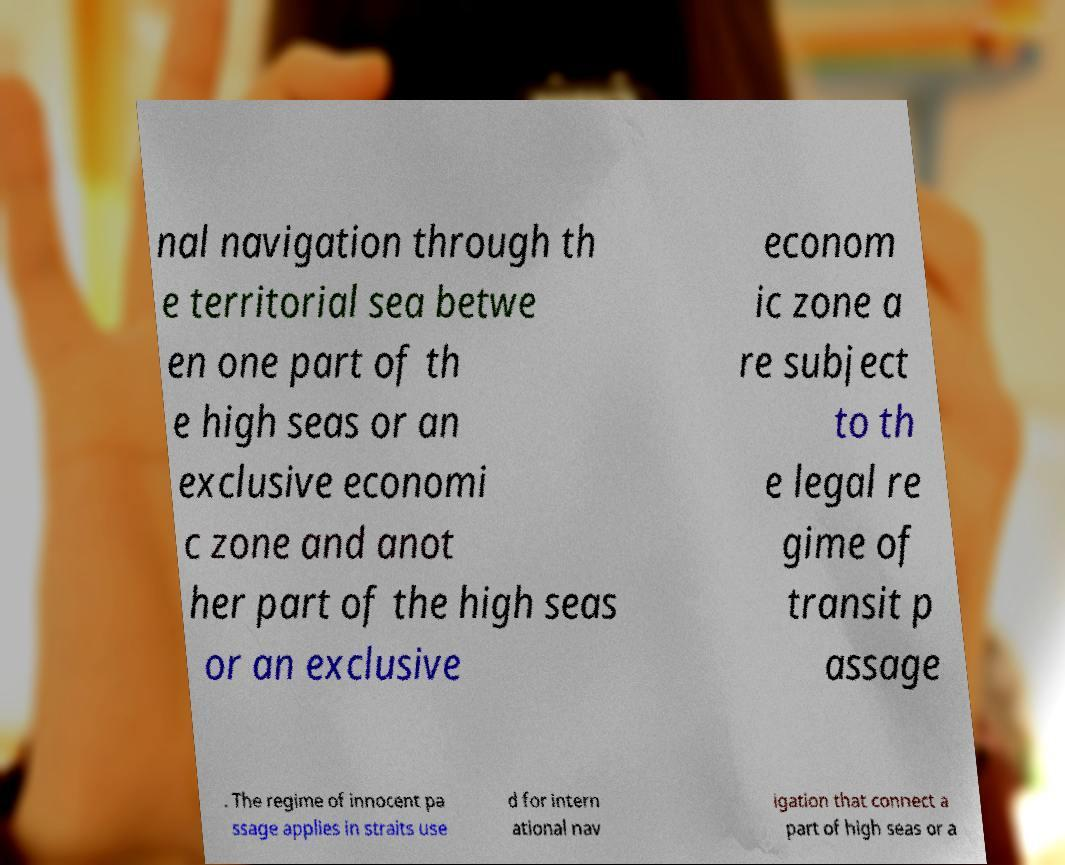Can you read and provide the text displayed in the image?This photo seems to have some interesting text. Can you extract and type it out for me? nal navigation through th e territorial sea betwe en one part of th e high seas or an exclusive economi c zone and anot her part of the high seas or an exclusive econom ic zone a re subject to th e legal re gime of transit p assage . The regime of innocent pa ssage applies in straits use d for intern ational nav igation that connect a part of high seas or a 